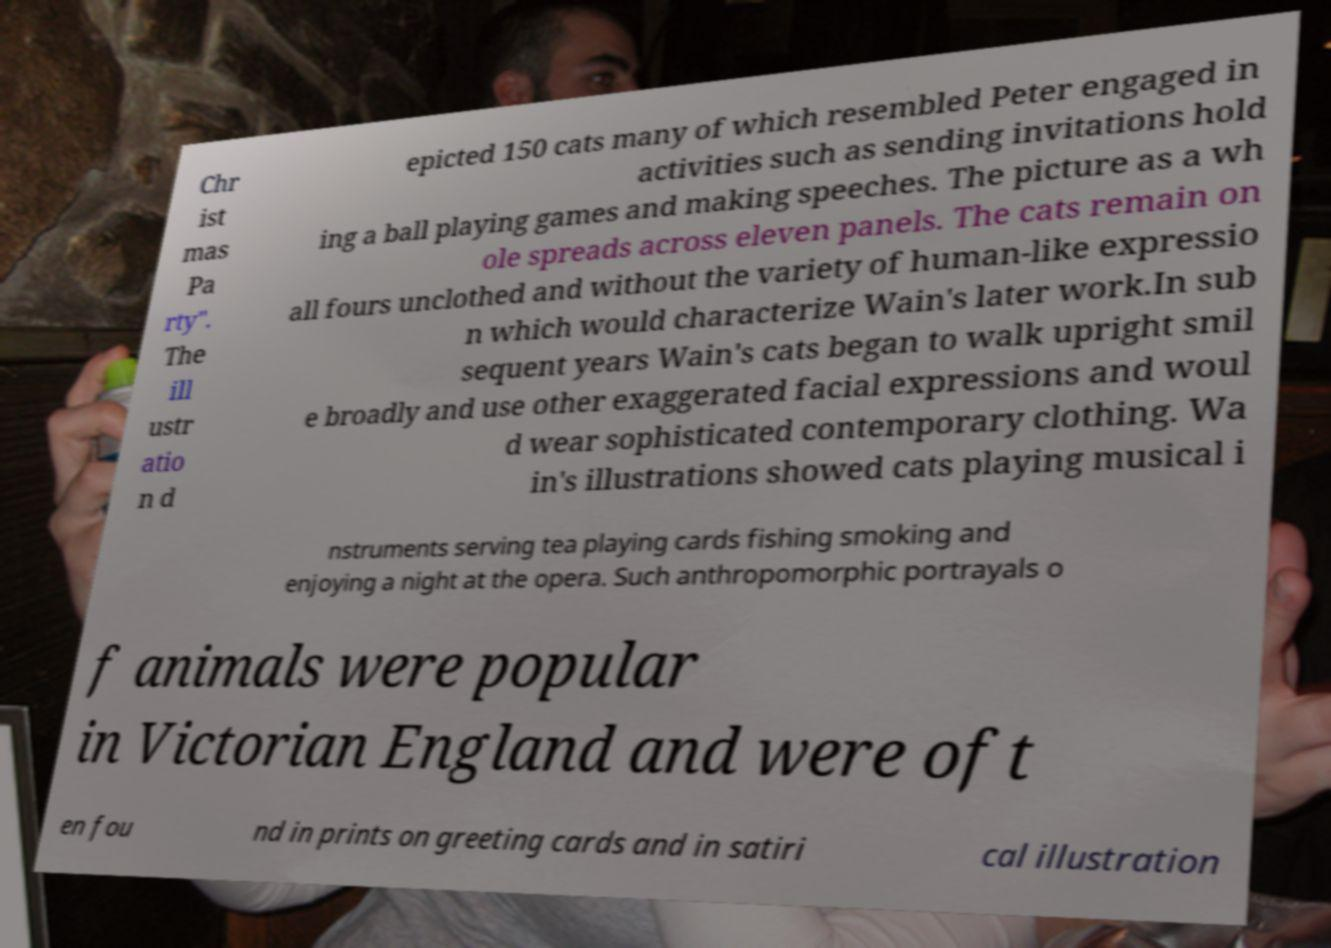Could you extract and type out the text from this image? Chr ist mas Pa rty". The ill ustr atio n d epicted 150 cats many of which resembled Peter engaged in activities such as sending invitations hold ing a ball playing games and making speeches. The picture as a wh ole spreads across eleven panels. The cats remain on all fours unclothed and without the variety of human-like expressio n which would characterize Wain's later work.In sub sequent years Wain's cats began to walk upright smil e broadly and use other exaggerated facial expressions and woul d wear sophisticated contemporary clothing. Wa in's illustrations showed cats playing musical i nstruments serving tea playing cards fishing smoking and enjoying a night at the opera. Such anthropomorphic portrayals o f animals were popular in Victorian England and were oft en fou nd in prints on greeting cards and in satiri cal illustration 